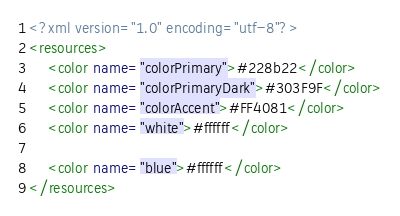<code> <loc_0><loc_0><loc_500><loc_500><_XML_><?xml version="1.0" encoding="utf-8"?>
<resources>
    <color name="colorPrimary">#228b22</color>
    <color name="colorPrimaryDark">#303F9F</color>
    <color name="colorAccent">#FF4081</color>
    <color name="white">#ffffff</color>

    <color name="blue">#ffffff</color>
</resources>
</code> 